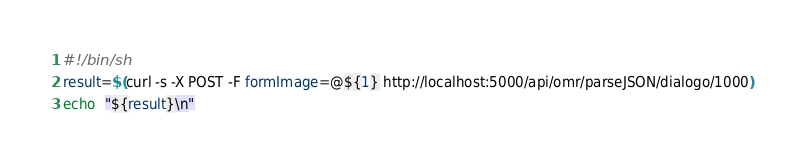Convert code to text. <code><loc_0><loc_0><loc_500><loc_500><_Bash_>#!/bin/sh
result=$(curl -s -X POST -F formImage=@${1} http://localhost:5000/api/omr/parseJSON/dialogo/1000)
echo  "${result}\n"
</code> 